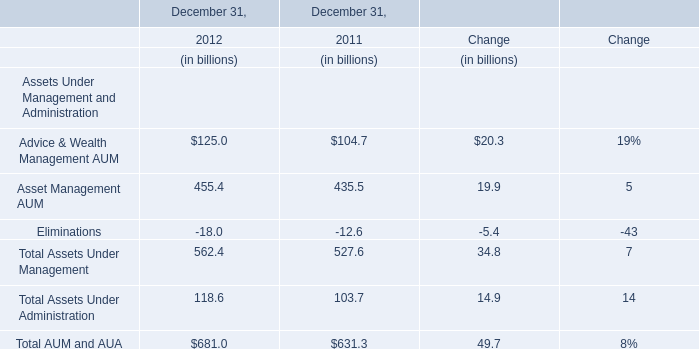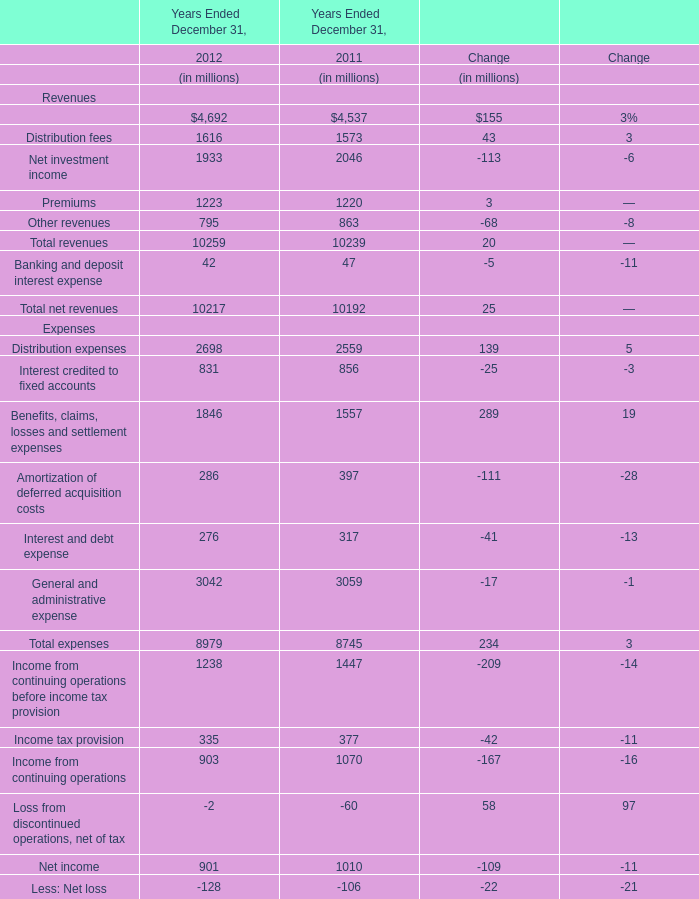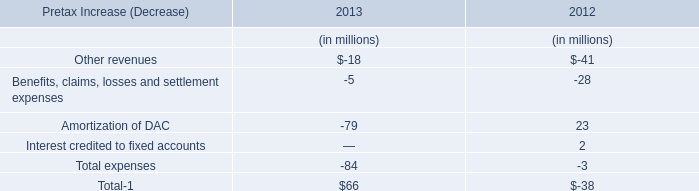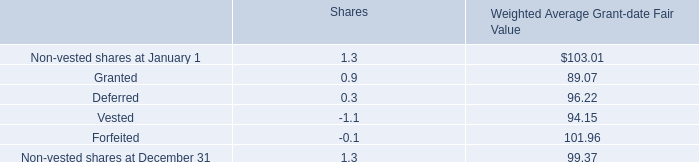What will Total AUM and AUA reach in 2013 if it continues to grow at its 2012 rate? (in billion) 
Computations: (681 * (1 + ((681 - 631.3) / 631.3)))
Answer: 734.6127. 